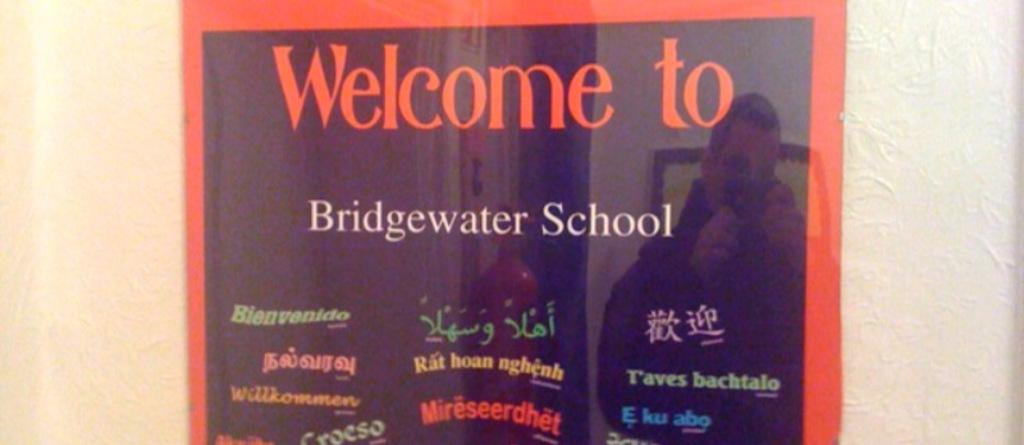Where is this sign welcoming you to?
Offer a terse response. Bridgewater school. What is the name of the school?
Provide a succinct answer. Bridgewater. 